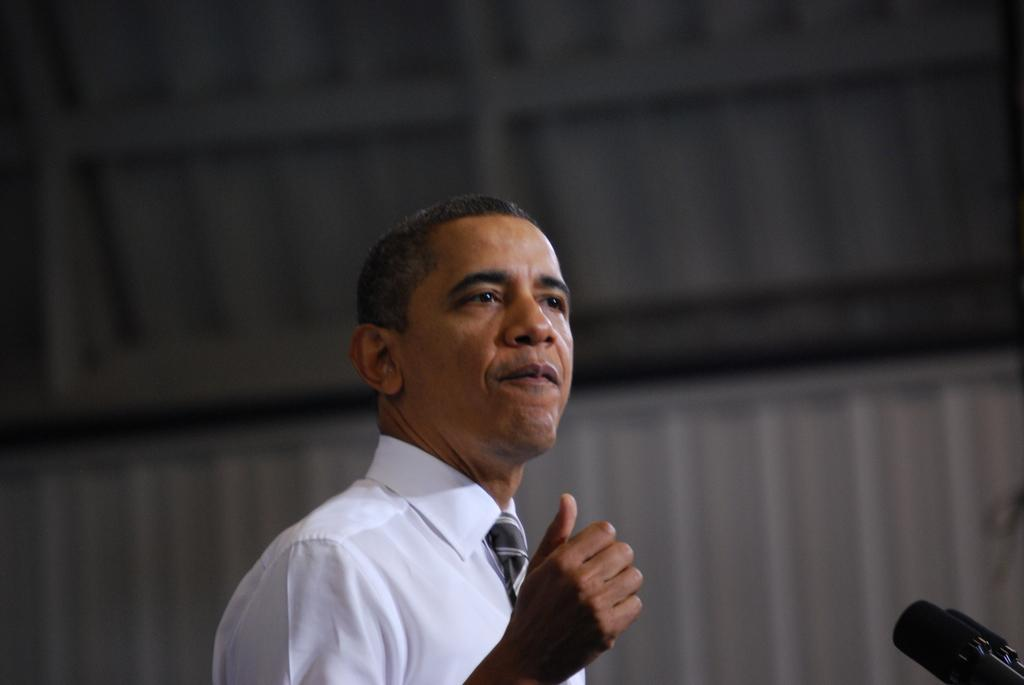Who or what is present in the image? There is a person in the image. What objects can be seen on the right side of the image? There are mics on the right side of the image. What type of cork can be seen in the image? There is no cork present in the image. How does the person in the image appear to be feeling in terms of comfort? The image does not provide information about the person's comfort level. 